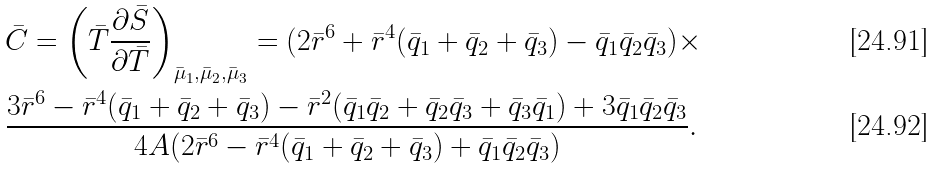Convert formula to latex. <formula><loc_0><loc_0><loc_500><loc_500>& \bar { C } = \left ( \bar { T } \frac { \partial \bar { S } } { \partial \bar { T } } \right ) _ { \bar { \mu } _ { 1 } , \bar { \mu } _ { 2 } , \bar { \mu } _ { 3 } } = ( 2 \bar { r } ^ { 6 } + \bar { r } ^ { 4 } ( \bar { q } _ { 1 } + \bar { q } _ { 2 } + \bar { q } _ { 3 } ) - \bar { q } _ { 1 } \bar { q } _ { 2 } \bar { q } _ { 3 } ) \times \\ & \frac { 3 \bar { r } ^ { 6 } - \bar { r } ^ { 4 } ( \bar { q } _ { 1 } + \bar { q } _ { 2 } + \bar { q } _ { 3 } ) - \bar { r } ^ { 2 } ( \bar { q } _ { 1 } \bar { q } _ { 2 } + \bar { q } _ { 2 } \bar { q } _ { 3 } + \bar { q } _ { 3 } \bar { q } _ { 1 } ) + 3 \bar { q } _ { 1 } \bar { q } _ { 2 } \bar { q } _ { 3 } } { 4 A ( 2 \bar { r } ^ { 6 } - \bar { r } ^ { 4 } ( \bar { q } _ { 1 } + \bar { q } _ { 2 } + \bar { q } _ { 3 } ) + \bar { q } _ { 1 } \bar { q } _ { 2 } \bar { q } _ { 3 } ) } .</formula> 